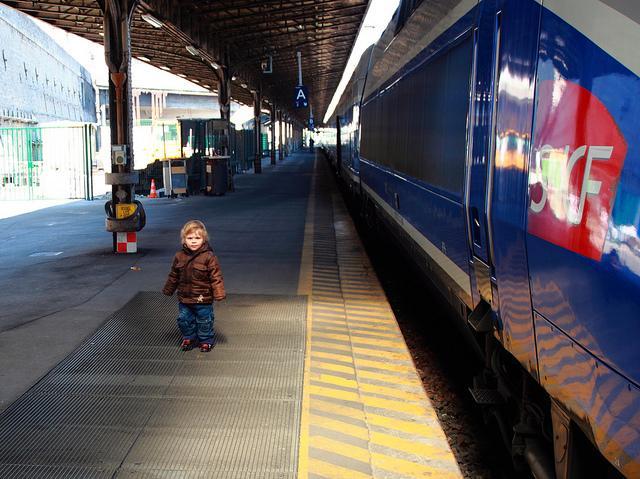What is this child's parent doing?

Choices:
A) taking photograph
B) working
C) escaping
D) abandoning it taking photograph 